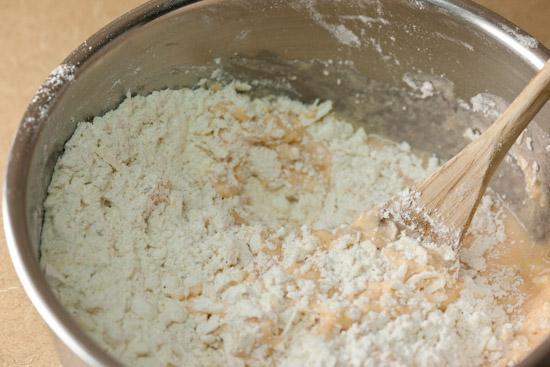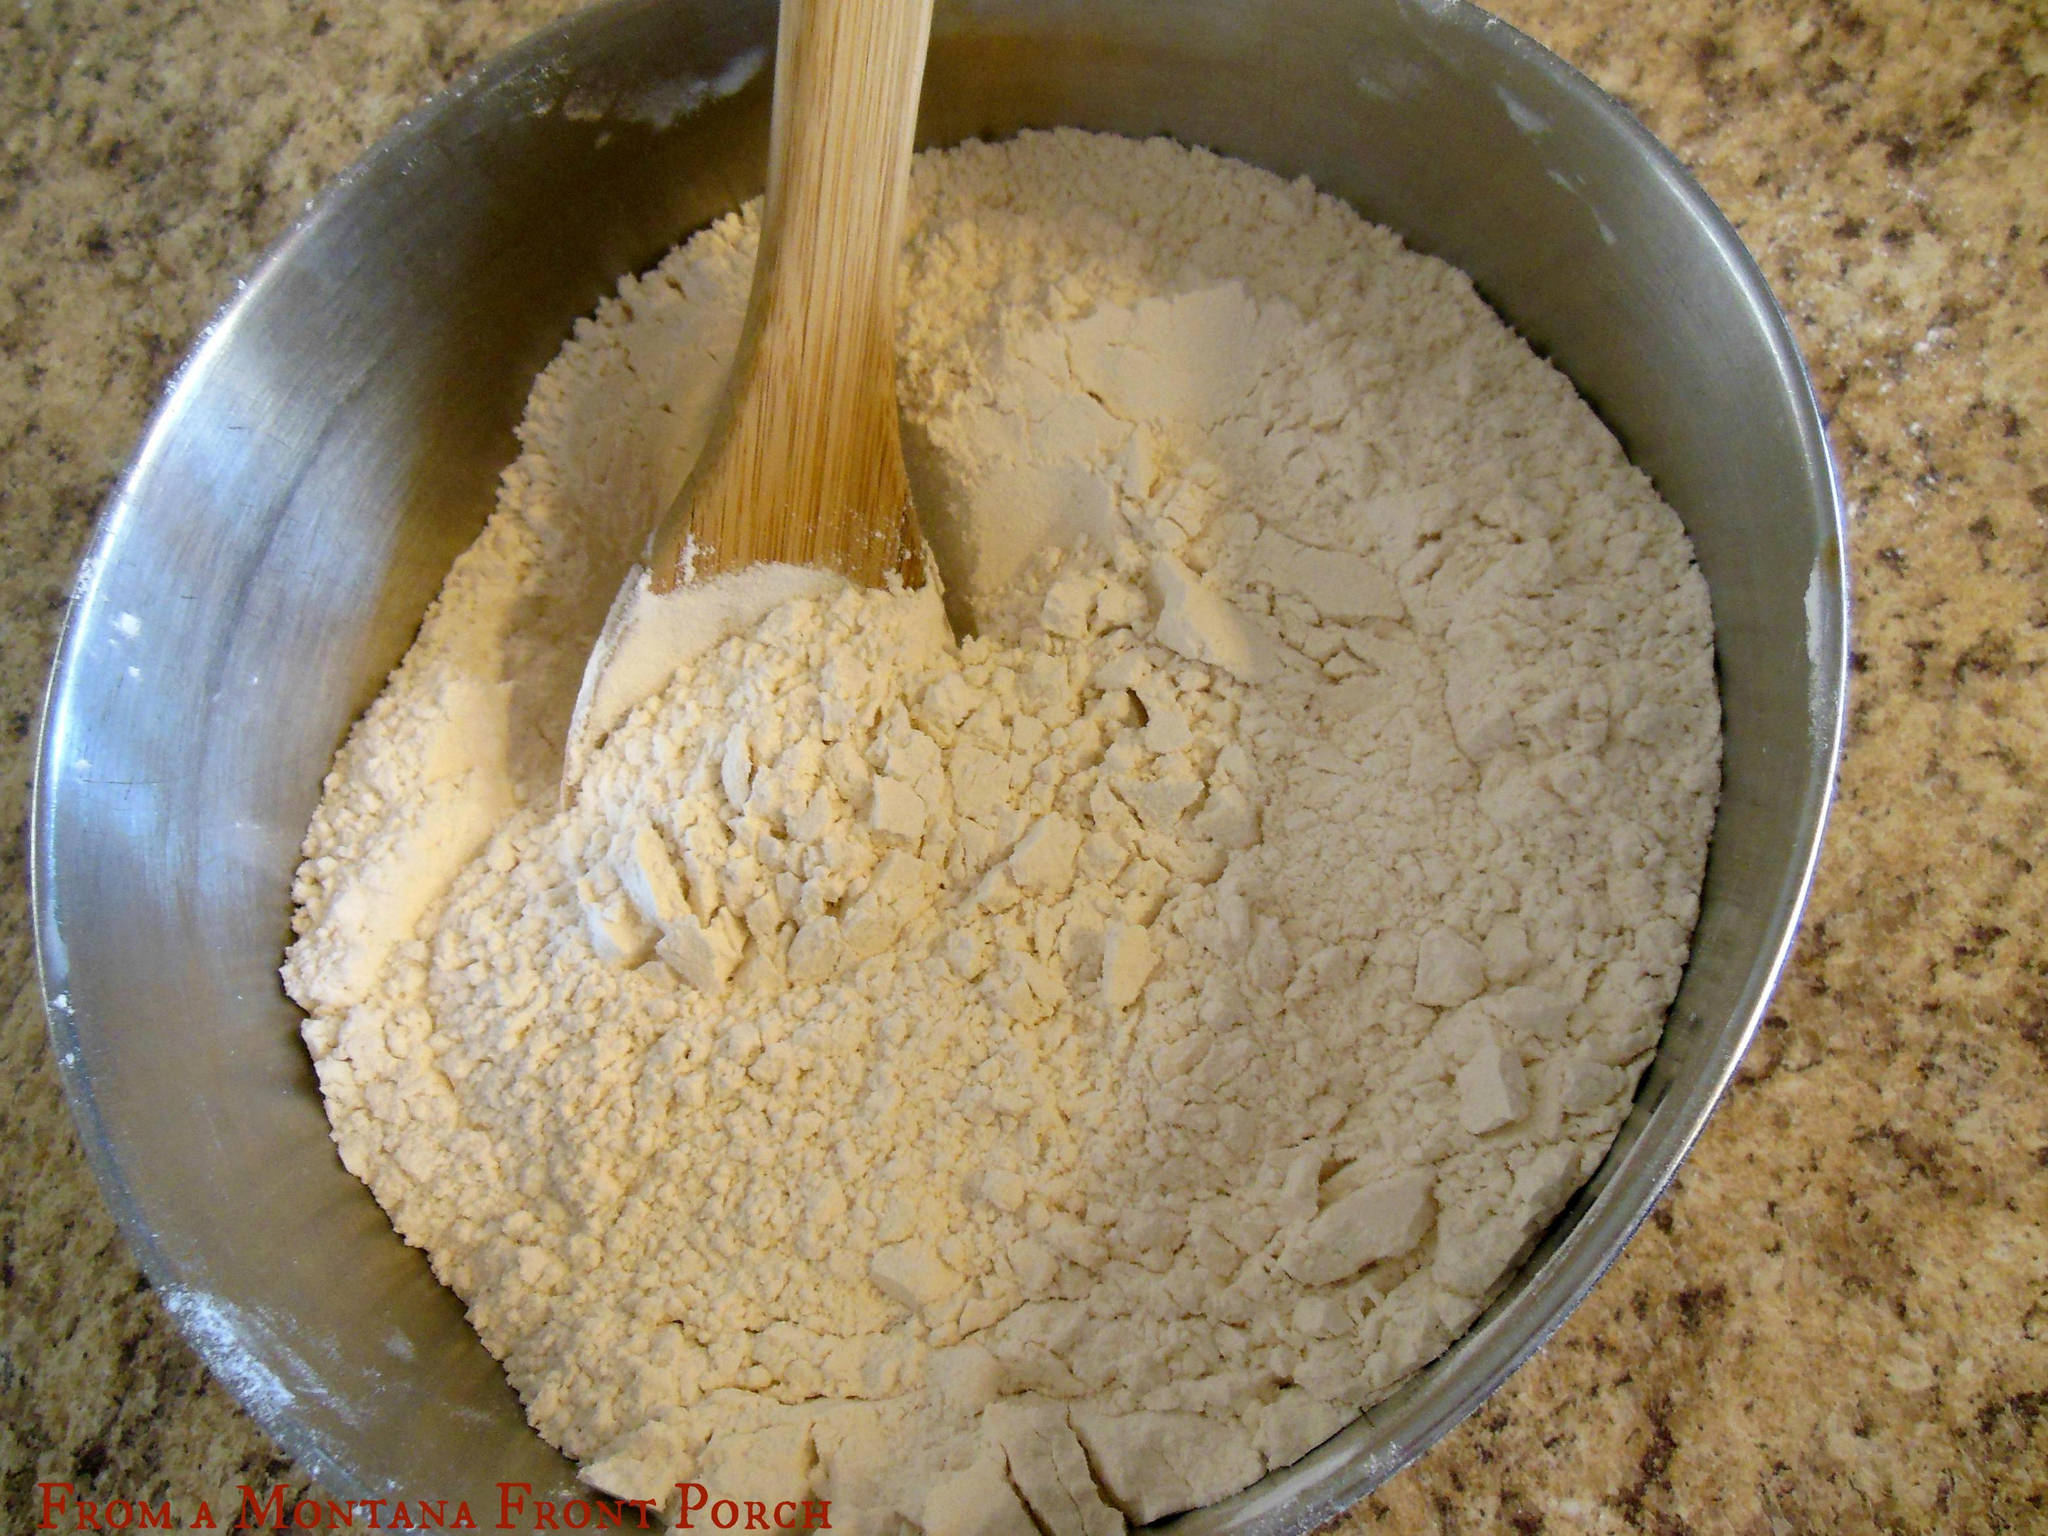The first image is the image on the left, the second image is the image on the right. Considering the images on both sides, is "Each image features a bowl of ingredients, with a utensil in the bowl and its one handle sticking out." valid? Answer yes or no. Yes. The first image is the image on the left, the second image is the image on the right. Examine the images to the left and right. Is the description "One of the images does not contain a handheld utensil." accurate? Answer yes or no. No. 